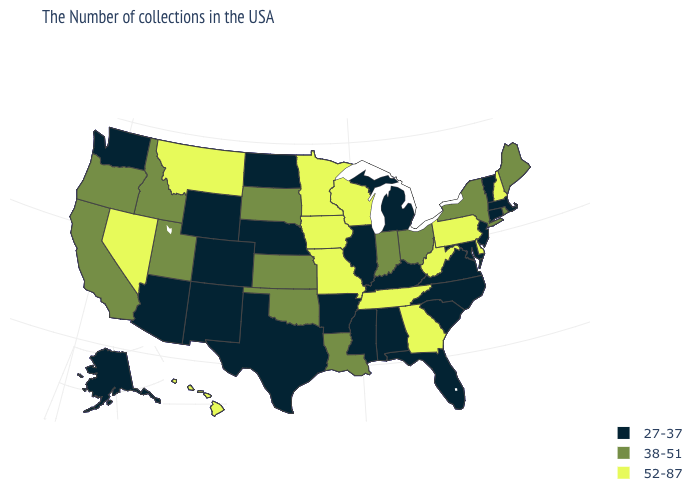What is the highest value in the USA?
Concise answer only. 52-87. What is the value of Vermont?
Write a very short answer. 27-37. Which states have the lowest value in the Northeast?
Give a very brief answer. Massachusetts, Vermont, Connecticut, New Jersey. Name the states that have a value in the range 38-51?
Answer briefly. Maine, Rhode Island, New York, Ohio, Indiana, Louisiana, Kansas, Oklahoma, South Dakota, Utah, Idaho, California, Oregon. Name the states that have a value in the range 27-37?
Give a very brief answer. Massachusetts, Vermont, Connecticut, New Jersey, Maryland, Virginia, North Carolina, South Carolina, Florida, Michigan, Kentucky, Alabama, Illinois, Mississippi, Arkansas, Nebraska, Texas, North Dakota, Wyoming, Colorado, New Mexico, Arizona, Washington, Alaska. What is the value of Oklahoma?
Keep it brief. 38-51. Name the states that have a value in the range 27-37?
Answer briefly. Massachusetts, Vermont, Connecticut, New Jersey, Maryland, Virginia, North Carolina, South Carolina, Florida, Michigan, Kentucky, Alabama, Illinois, Mississippi, Arkansas, Nebraska, Texas, North Dakota, Wyoming, Colorado, New Mexico, Arizona, Washington, Alaska. Does Connecticut have the highest value in the Northeast?
Short answer required. No. Which states have the lowest value in the West?
Concise answer only. Wyoming, Colorado, New Mexico, Arizona, Washington, Alaska. Among the states that border South Carolina , does Georgia have the highest value?
Concise answer only. Yes. Name the states that have a value in the range 27-37?
Keep it brief. Massachusetts, Vermont, Connecticut, New Jersey, Maryland, Virginia, North Carolina, South Carolina, Florida, Michigan, Kentucky, Alabama, Illinois, Mississippi, Arkansas, Nebraska, Texas, North Dakota, Wyoming, Colorado, New Mexico, Arizona, Washington, Alaska. What is the value of Rhode Island?
Concise answer only. 38-51. Among the states that border Georgia , does Tennessee have the lowest value?
Answer briefly. No. What is the value of Massachusetts?
Be succinct. 27-37. Name the states that have a value in the range 52-87?
Short answer required. New Hampshire, Delaware, Pennsylvania, West Virginia, Georgia, Tennessee, Wisconsin, Missouri, Minnesota, Iowa, Montana, Nevada, Hawaii. 